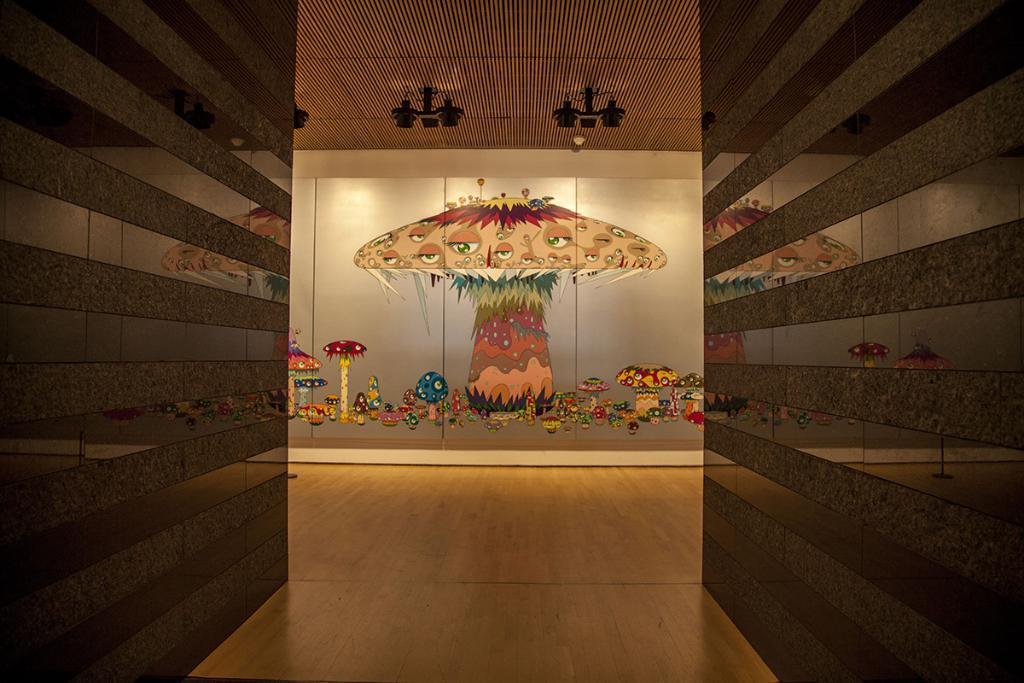In one or two sentences, can you explain what this image depicts? In this image I can see two walls which are brown and black in color and the brown colored surface. In the background i can see the wall on which I can see the painting of few mushrooms which are blue, red, brown, yellow and pink in colors, I can see the brown colored ceiling and few lights to the ceiling. 